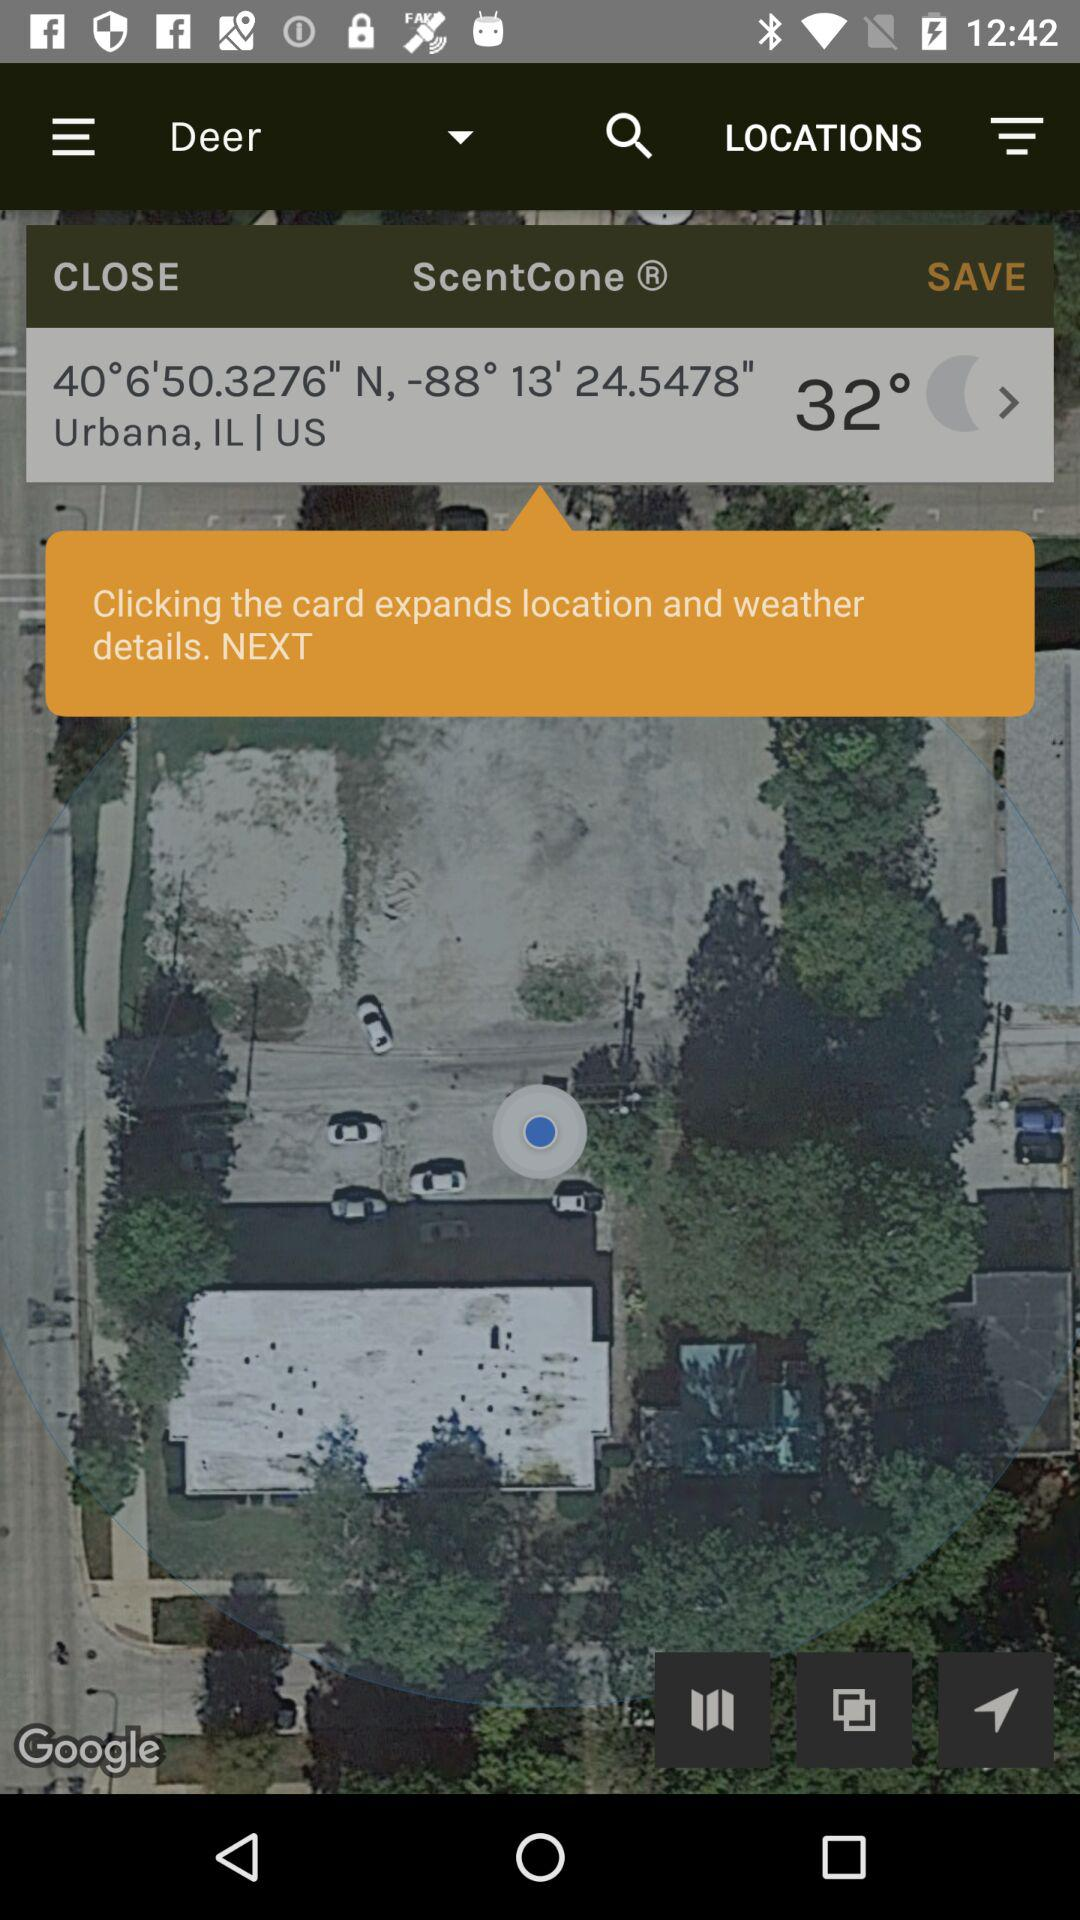What is the temperature? The temperature is 32°. 